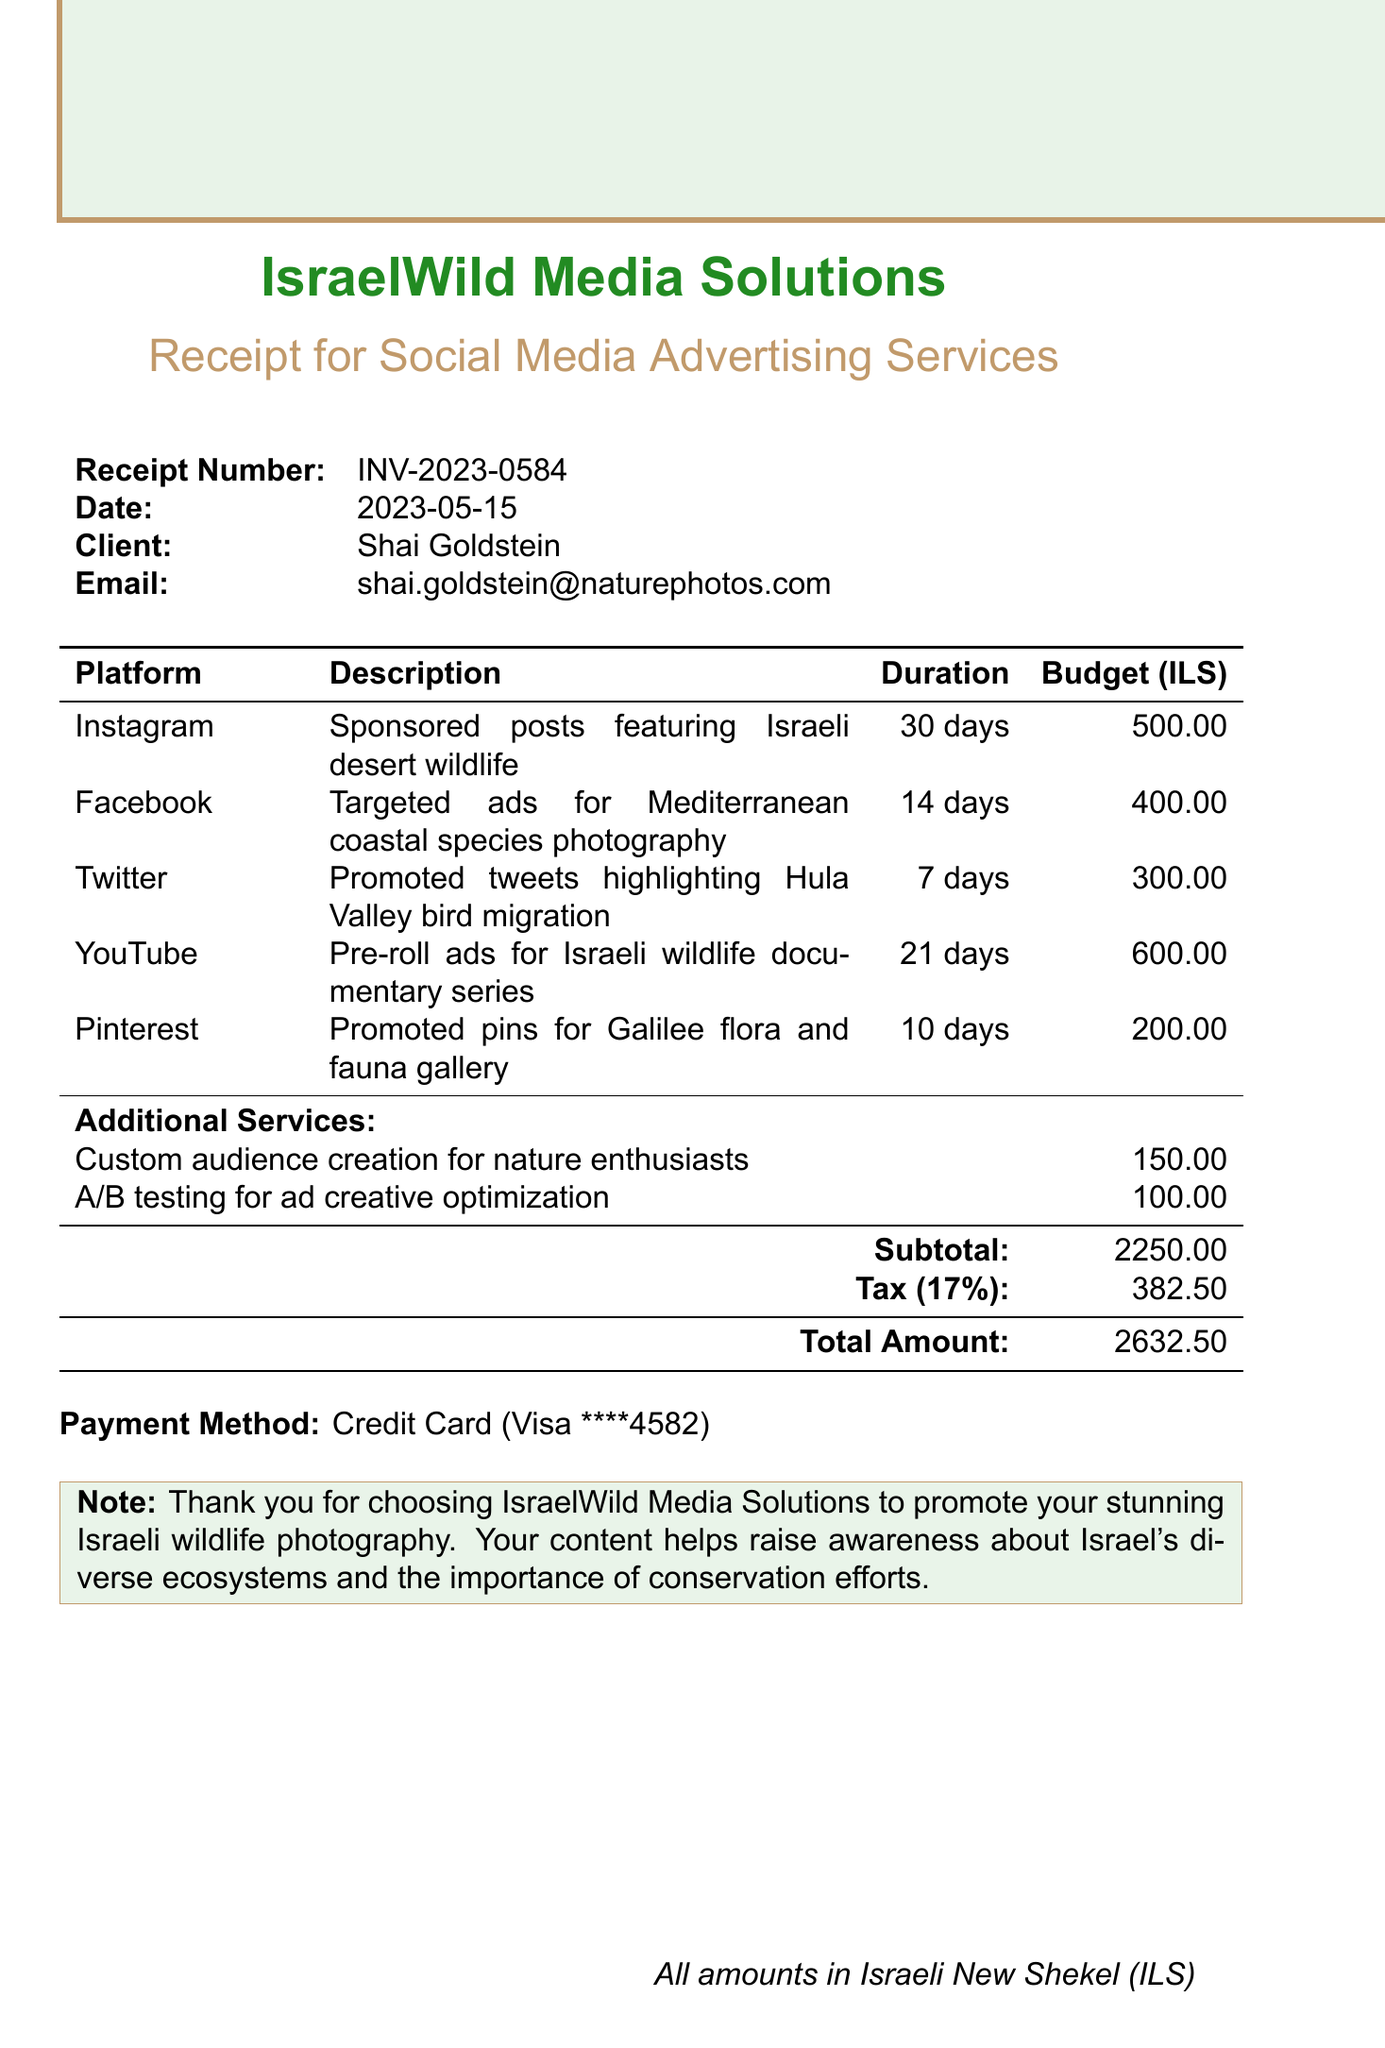What is the receipt number? The receipt number is specified in the document as a unique identifier for the transaction.
Answer: INV-2023-0584 What is the total amount due? The total amount is the final sum calculated after adding the subtotal and tax amount.
Answer: 2632.50 Who is the client? The client is the individual named in the document who is receiving the services.
Answer: Shai Goldstein What service is provided for Instagram? The document lists the specific service related to the Instagram platform.
Answer: Sponsored posts featuring Israeli desert wildlife What is the budget allocated for Facebook ads? The document specifies the financial allocation for Facebook advertisements.
Answer: 400 What is the duration of the Twitter promotion? The document outlines how long the Twitter promotion will run.
Answer: 7 days What does the note thank the client for? The note expresses gratitude for the client's choice of the service provider.
Answer: Promoting stunning Israeli wildlife photography How much is the cost for custom audience creation? The document lists the cost associated with this specific additional service.
Answer: 150 What payment method was used? The payment method indicates how the total amount was settled.
Answer: Credit Card What is the tax rate applied? The document includes the tax rate that was applied to the subtotal.
Answer: 17% 